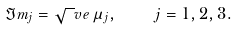<formula> <loc_0><loc_0><loc_500><loc_500>\Im m _ { j } = \sqrt { \ } v e \, \mu _ { j } , \quad j = 1 , 2 , 3 .</formula> 